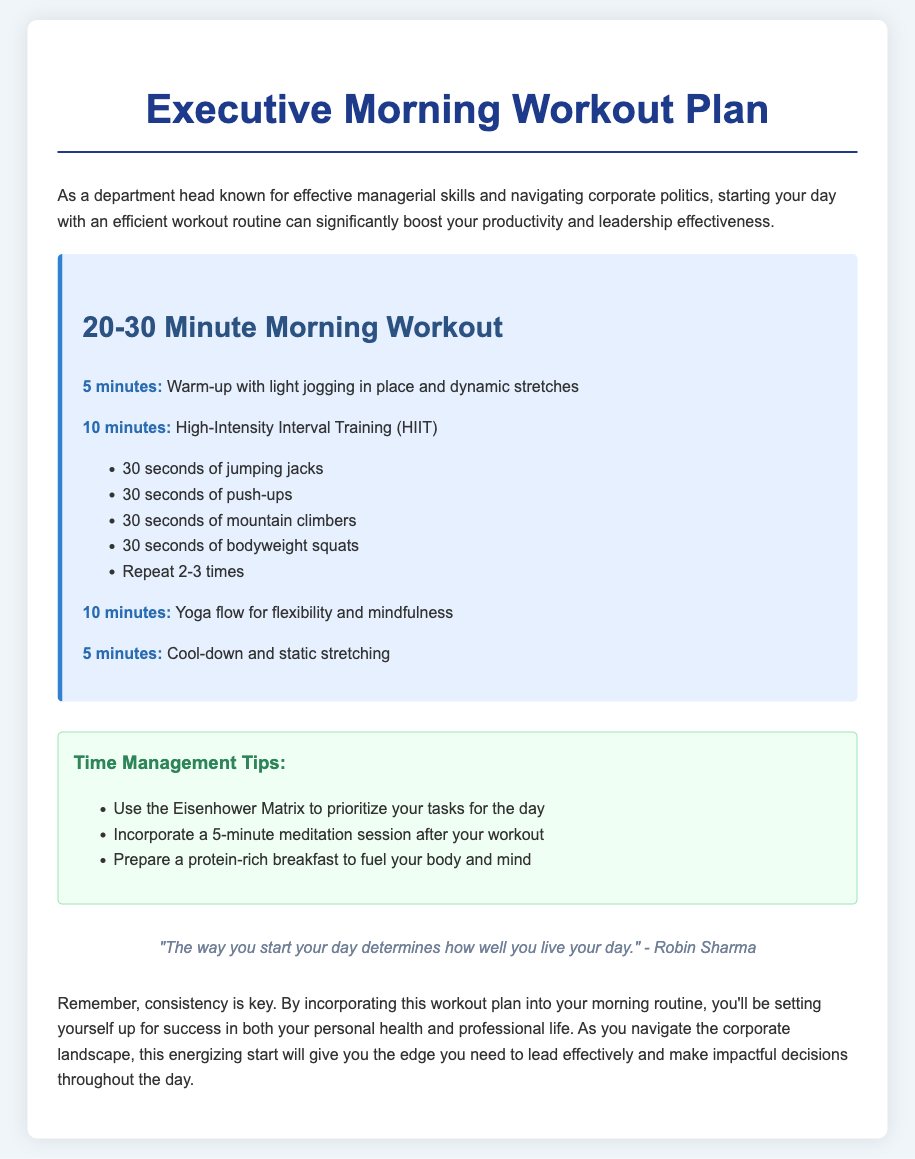What is the warm-up duration? The document states that the warm-up duration is 5 minutes.
Answer: 5 minutes How many minutes are allocated for HIIT? The document specifies that 10 minutes are allocated for High-Intensity Interval Training (HIIT).
Answer: 10 minutes What is the last activity in the workout plan? The last activity mentioned in the workout plan is cool-down and static stretching.
Answer: Cool-down and static stretching What is included in the Time Management Tips? The document lists a variety of time management tips, including using the Eisenhower Matrix to prioritize tasks.
Answer: Use the Eisenhower Matrix How many times should the HIIT exercises be repeated? The suggested repetition for the HIIT exercises is 2-3 times.
Answer: 2-3 times What is the main purpose of this morning workout plan? The document indicates that the main purpose is to boost productivity and leadership effectiveness.
Answer: To boost productivity and leadership effectiveness What should be prepared for breakfast according to the tips? The document states that a protein-rich breakfast should be prepared.
Answer: Protein-rich breakfast What type of training is focused on flexibility and mindfulness? The document specifies that yoga flow is the training focused on flexibility and mindfulness.
Answer: Yoga flow 